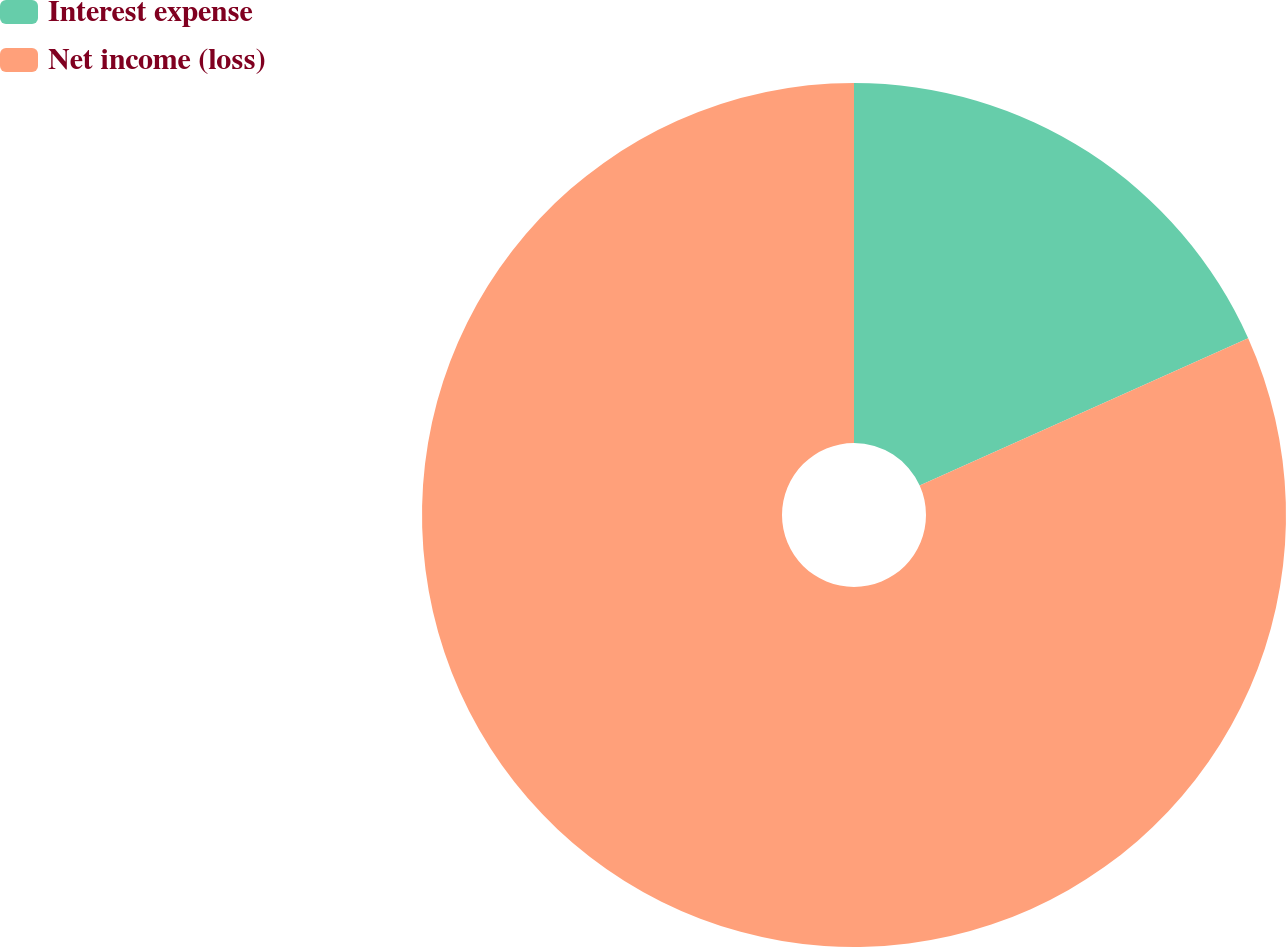Convert chart to OTSL. <chart><loc_0><loc_0><loc_500><loc_500><pie_chart><fcel>Interest expense<fcel>Net income (loss)<nl><fcel>18.29%<fcel>81.71%<nl></chart> 